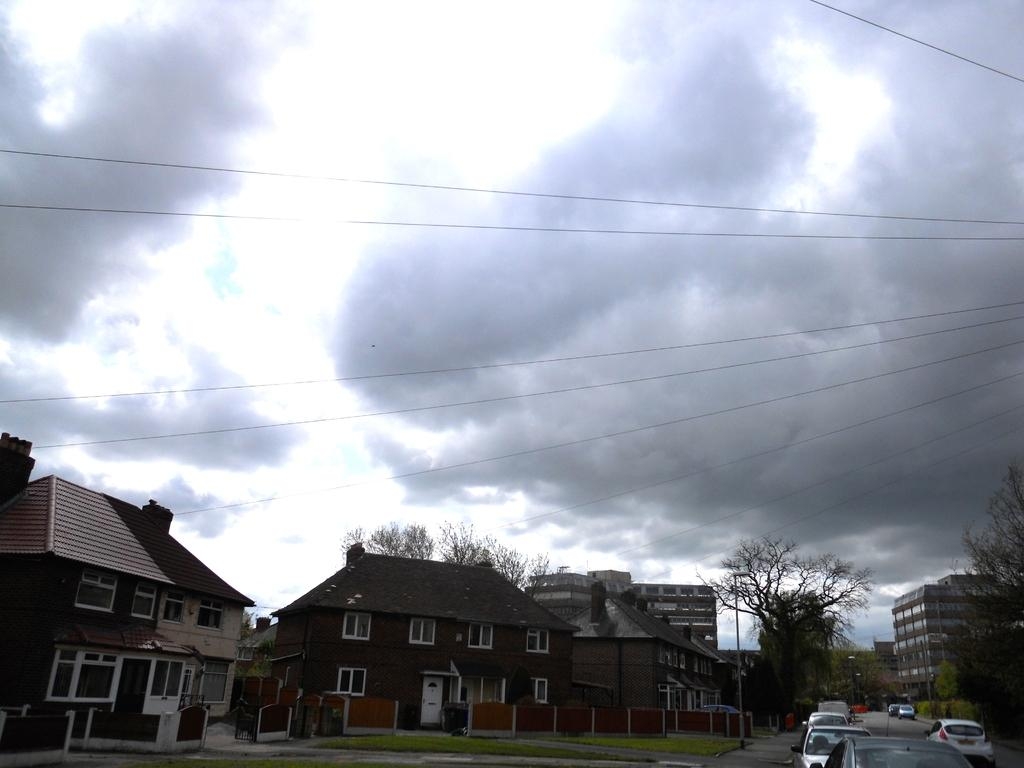What can be seen on the right side of the image? There is a road on the right side of the image. What is happening on the road? There are cars on the road. What type of structures can be seen in the image? There are homes visible in the image. What else can be seen in the image besides the road and homes? There are trees in the image. What is visible at the top of the image? The sky is visible at the top of the image. How would you describe the sky in the image? The sky is cloudy. Where is the doll placed in the image? There is no doll present in the image. What type of cart is being pulled by the horses in the image? There are no horses or carts present in the image. 